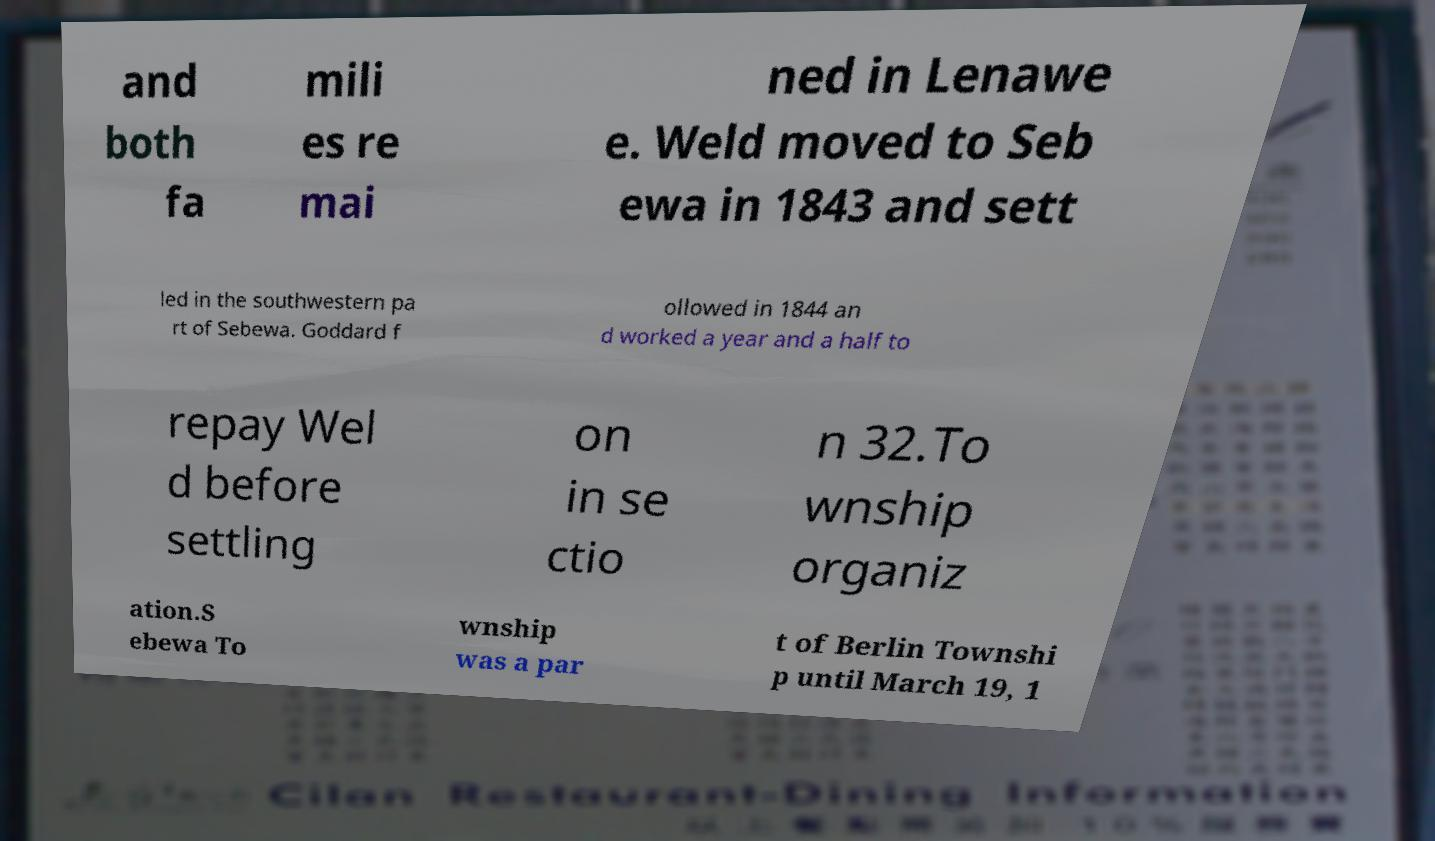For documentation purposes, I need the text within this image transcribed. Could you provide that? and both fa mili es re mai ned in Lenawe e. Weld moved to Seb ewa in 1843 and sett led in the southwestern pa rt of Sebewa. Goddard f ollowed in 1844 an d worked a year and a half to repay Wel d before settling on in se ctio n 32.To wnship organiz ation.S ebewa To wnship was a par t of Berlin Townshi p until March 19, 1 